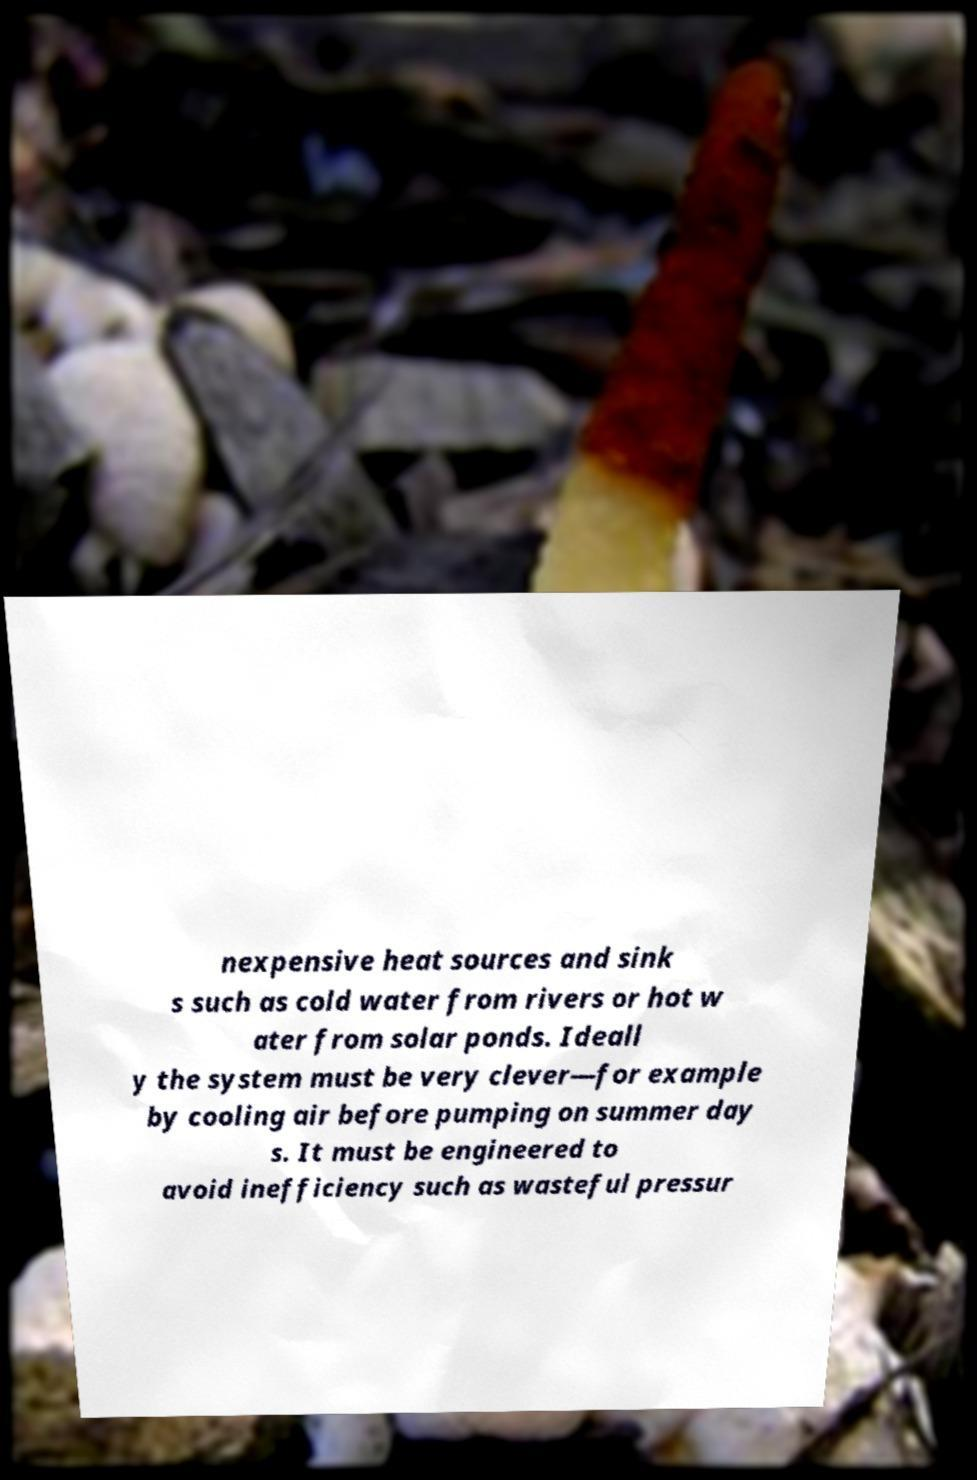Please read and relay the text visible in this image. What does it say? nexpensive heat sources and sink s such as cold water from rivers or hot w ater from solar ponds. Ideall y the system must be very clever—for example by cooling air before pumping on summer day s. It must be engineered to avoid inefficiency such as wasteful pressur 